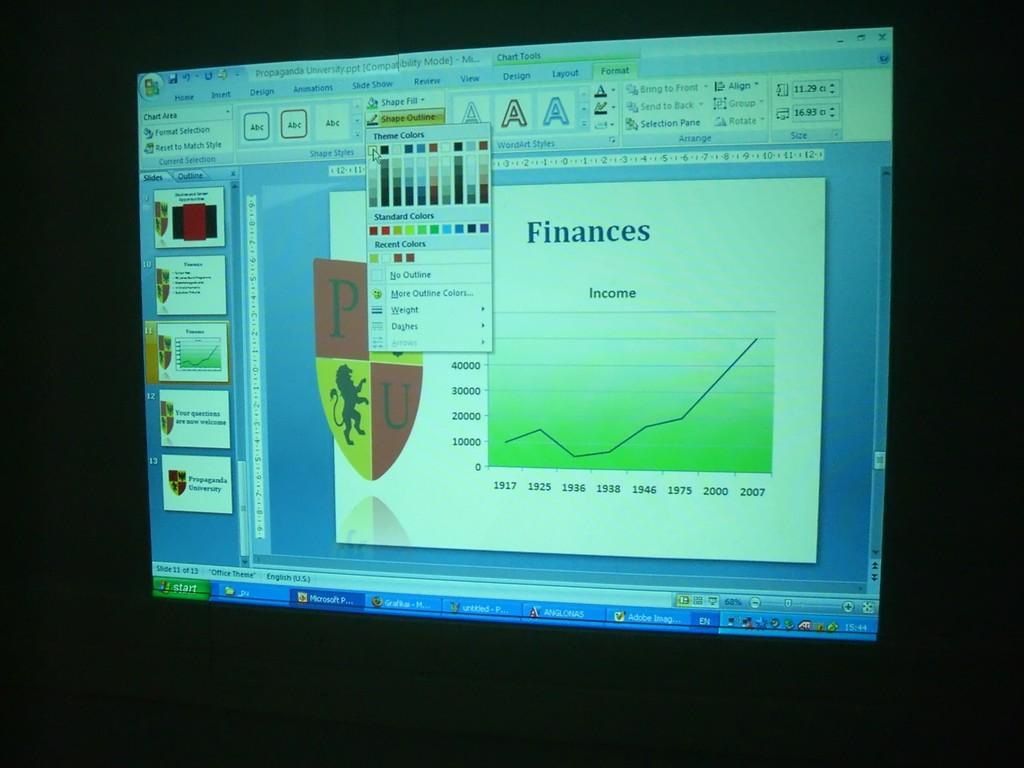<image>
Describe the image concisely. a computer screen with an editing program opened to finances 